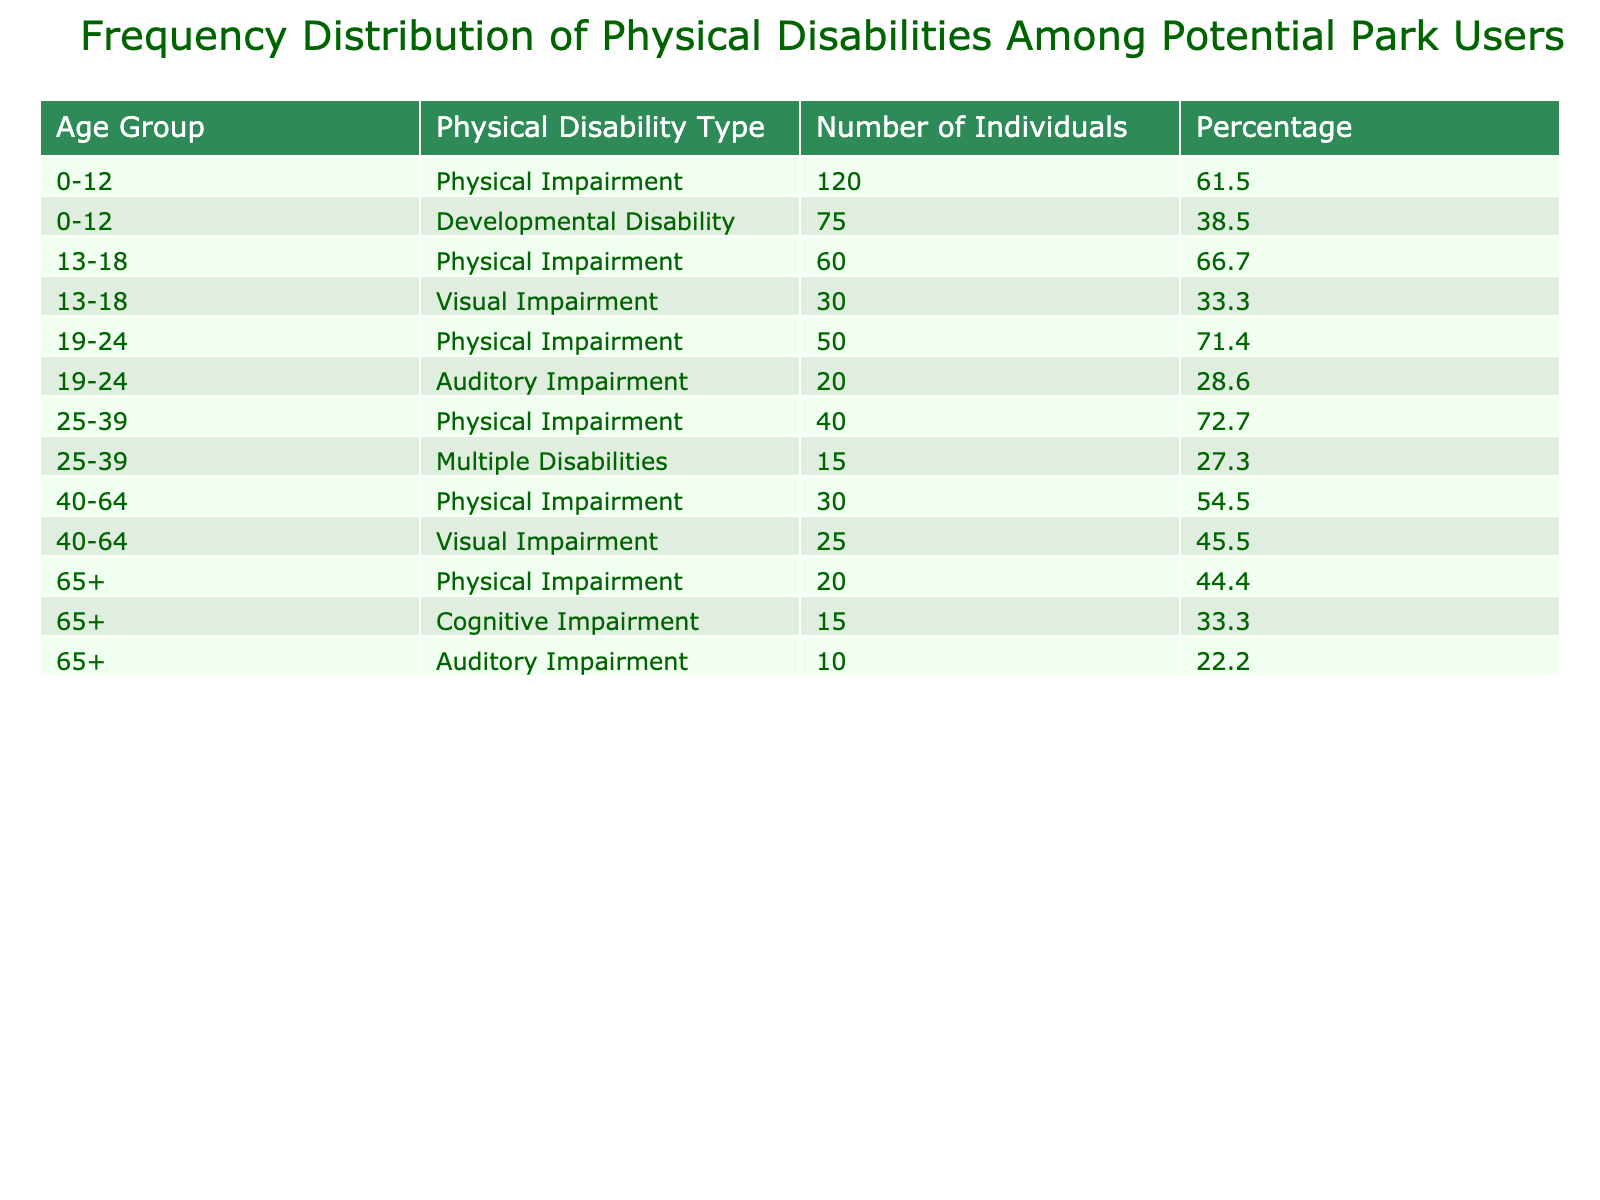What is the total number of individuals with physical impairments in the age group 0-12? In the age group 0-12, the number of individuals with physical impairments is 120. This is directly taken from the table data for that age group and disability type.
Answer: 120 How many individuals in the 40-64 age group have visual impairments? The table lists 25 individuals in the age group 40-64 who have visual impairments. This information is explicitly mentioned in the data.
Answer: 25 What percentage of individuals in the 19-24 age group has auditory impairments? To find this percentage, we first identify that there are 20 individuals with auditory impairments in this age group. The total for the age group is 50 (physical impairment) + 20 (auditory impairment) = 70. The percentage is (20/70) * 100, which equals approximately 28.6%.
Answer: 28.6 Are there any individuals aged 65+ who have developmental disabilities? The data does not list any individuals aged 65 and over with developmental disabilities; all entries for this age group are focused on physical, cognitive, and auditory impairments.
Answer: No What is the combined total of individuals across all age groups who have multiple disabilities? There is only one entry for multiple disabilities, which is 15 individuals in the 25-39 age group. To find the total, we simply take this single value: 15. There are no other entries for multiple disabilities in any other age group.
Answer: 15 What is the average number of individuals with physical impairments across all age groups? We sum the number of individuals with physical impairments from each age group: 120 (0-12) + 60 (13-18) + 50 (19-24) + 40 (25-39) + 30 (40-64) + 20 (65+) = 320. There are 6 age groups so the average is 320/6 = approximately 53.3.
Answer: 53.3 How many individuals are there in total across all disability types in the 0-12 age group? For the 0-12 age group, we sum both disability types: 120 (physical impairment) + 75 (developmental disability) = 195. This provides the total number who fall under any disability in that age category.
Answer: 195 What is the difference in the number of individuals with cognitive impairments compared to those with auditory impairments in the age group 65+? In the age group 65+, there are 15 individuals with cognitive impairments and 10 with auditory impairments. The difference is 15 - 10 = 5. This step ensures we quantify the gap in these specific impairments for older adults.
Answer: 5 